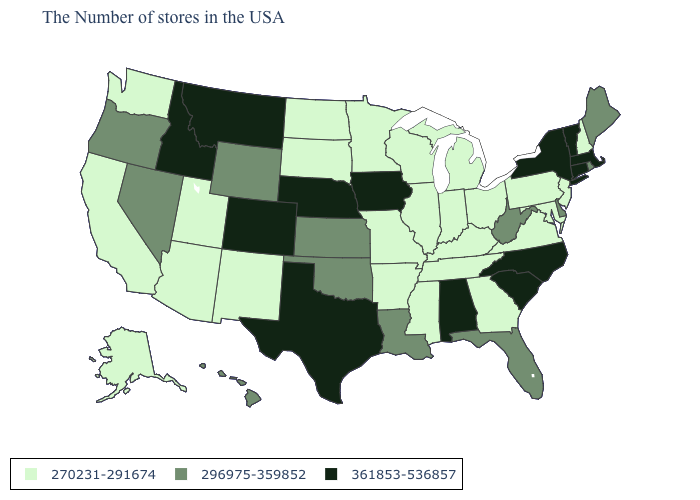Among the states that border Texas , which have the lowest value?
Answer briefly. Arkansas, New Mexico. Name the states that have a value in the range 270231-291674?
Write a very short answer. New Hampshire, New Jersey, Maryland, Pennsylvania, Virginia, Ohio, Georgia, Michigan, Kentucky, Indiana, Tennessee, Wisconsin, Illinois, Mississippi, Missouri, Arkansas, Minnesota, South Dakota, North Dakota, New Mexico, Utah, Arizona, California, Washington, Alaska. What is the value of Florida?
Quick response, please. 296975-359852. What is the value of Oregon?
Quick response, please. 296975-359852. Does the first symbol in the legend represent the smallest category?
Short answer required. Yes. What is the value of Washington?
Be succinct. 270231-291674. Name the states that have a value in the range 296975-359852?
Keep it brief. Maine, Rhode Island, Delaware, West Virginia, Florida, Louisiana, Kansas, Oklahoma, Wyoming, Nevada, Oregon, Hawaii. What is the value of Florida?
Quick response, please. 296975-359852. What is the highest value in the Northeast ?
Quick response, please. 361853-536857. Name the states that have a value in the range 270231-291674?
Write a very short answer. New Hampshire, New Jersey, Maryland, Pennsylvania, Virginia, Ohio, Georgia, Michigan, Kentucky, Indiana, Tennessee, Wisconsin, Illinois, Mississippi, Missouri, Arkansas, Minnesota, South Dakota, North Dakota, New Mexico, Utah, Arizona, California, Washington, Alaska. Does South Dakota have a higher value than Indiana?
Concise answer only. No. What is the value of Wisconsin?
Concise answer only. 270231-291674. Does the map have missing data?
Keep it brief. No. Which states have the highest value in the USA?
Be succinct. Massachusetts, Vermont, Connecticut, New York, North Carolina, South Carolina, Alabama, Iowa, Nebraska, Texas, Colorado, Montana, Idaho. What is the value of New Mexico?
Write a very short answer. 270231-291674. 